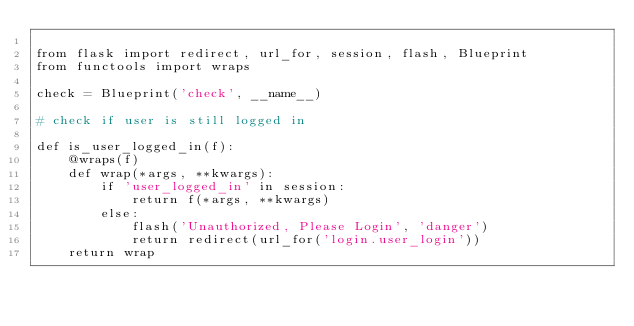Convert code to text. <code><loc_0><loc_0><loc_500><loc_500><_Python_>
from flask import redirect, url_for, session, flash, Blueprint
from functools import wraps

check = Blueprint('check', __name__)

# check if user is still logged in

def is_user_logged_in(f):
    @wraps(f)
    def wrap(*args, **kwargs):
        if 'user_logged_in' in session:
            return f(*args, **kwargs)
        else:
            flash('Unauthorized, Please Login', 'danger')
            return redirect(url_for('login.user_login'))
    return wrap</code> 